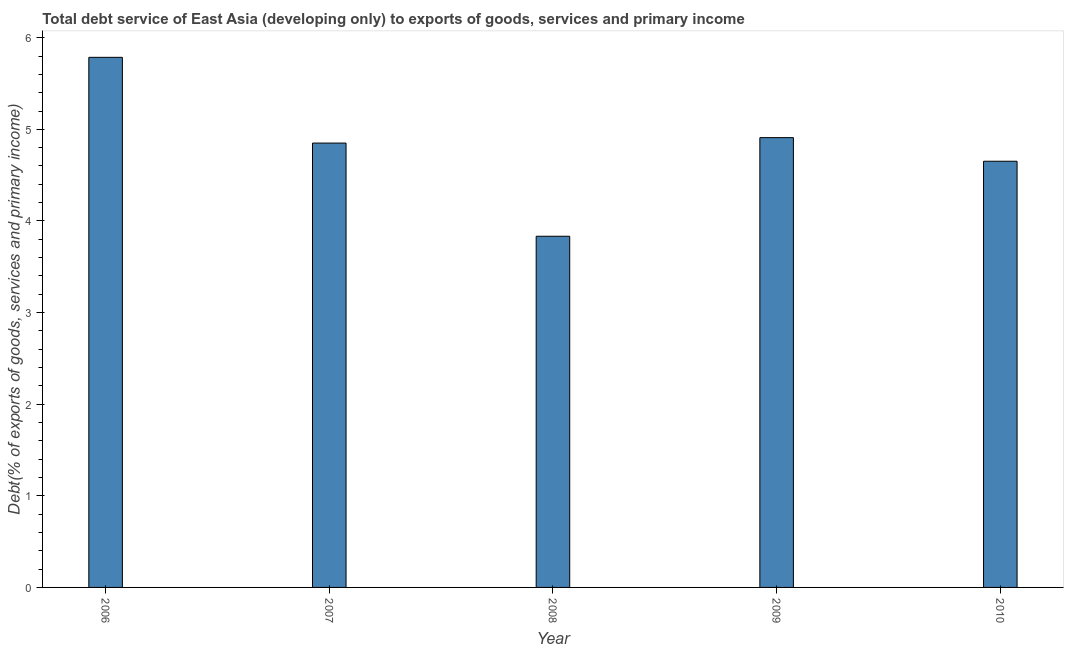Does the graph contain any zero values?
Your answer should be very brief. No. Does the graph contain grids?
Offer a terse response. No. What is the title of the graph?
Your answer should be very brief. Total debt service of East Asia (developing only) to exports of goods, services and primary income. What is the label or title of the Y-axis?
Ensure brevity in your answer.  Debt(% of exports of goods, services and primary income). What is the total debt service in 2008?
Ensure brevity in your answer.  3.83. Across all years, what is the maximum total debt service?
Keep it short and to the point. 5.79. Across all years, what is the minimum total debt service?
Keep it short and to the point. 3.83. In which year was the total debt service maximum?
Your answer should be compact. 2006. In which year was the total debt service minimum?
Offer a very short reply. 2008. What is the sum of the total debt service?
Ensure brevity in your answer.  24.03. What is the difference between the total debt service in 2009 and 2010?
Your answer should be very brief. 0.26. What is the average total debt service per year?
Offer a terse response. 4.81. What is the median total debt service?
Provide a short and direct response. 4.85. Do a majority of the years between 2008 and 2007 (inclusive) have total debt service greater than 0.2 %?
Your response must be concise. No. What is the ratio of the total debt service in 2006 to that in 2009?
Your answer should be very brief. 1.18. Is the total debt service in 2006 less than that in 2008?
Offer a terse response. No. What is the difference between the highest and the second highest total debt service?
Give a very brief answer. 0.88. Is the sum of the total debt service in 2008 and 2010 greater than the maximum total debt service across all years?
Give a very brief answer. Yes. What is the difference between the highest and the lowest total debt service?
Offer a very short reply. 1.95. In how many years, is the total debt service greater than the average total debt service taken over all years?
Your answer should be compact. 3. How many bars are there?
Ensure brevity in your answer.  5. How many years are there in the graph?
Your answer should be compact. 5. What is the Debt(% of exports of goods, services and primary income) in 2006?
Your answer should be very brief. 5.79. What is the Debt(% of exports of goods, services and primary income) of 2007?
Make the answer very short. 4.85. What is the Debt(% of exports of goods, services and primary income) in 2008?
Your answer should be very brief. 3.83. What is the Debt(% of exports of goods, services and primary income) in 2009?
Offer a terse response. 4.91. What is the Debt(% of exports of goods, services and primary income) in 2010?
Ensure brevity in your answer.  4.65. What is the difference between the Debt(% of exports of goods, services and primary income) in 2006 and 2007?
Ensure brevity in your answer.  0.94. What is the difference between the Debt(% of exports of goods, services and primary income) in 2006 and 2008?
Give a very brief answer. 1.95. What is the difference between the Debt(% of exports of goods, services and primary income) in 2006 and 2009?
Provide a short and direct response. 0.88. What is the difference between the Debt(% of exports of goods, services and primary income) in 2006 and 2010?
Your answer should be very brief. 1.13. What is the difference between the Debt(% of exports of goods, services and primary income) in 2007 and 2008?
Keep it short and to the point. 1.02. What is the difference between the Debt(% of exports of goods, services and primary income) in 2007 and 2009?
Offer a terse response. -0.06. What is the difference between the Debt(% of exports of goods, services and primary income) in 2007 and 2010?
Keep it short and to the point. 0.2. What is the difference between the Debt(% of exports of goods, services and primary income) in 2008 and 2009?
Offer a terse response. -1.08. What is the difference between the Debt(% of exports of goods, services and primary income) in 2008 and 2010?
Ensure brevity in your answer.  -0.82. What is the difference between the Debt(% of exports of goods, services and primary income) in 2009 and 2010?
Offer a very short reply. 0.26. What is the ratio of the Debt(% of exports of goods, services and primary income) in 2006 to that in 2007?
Your answer should be compact. 1.19. What is the ratio of the Debt(% of exports of goods, services and primary income) in 2006 to that in 2008?
Your answer should be compact. 1.51. What is the ratio of the Debt(% of exports of goods, services and primary income) in 2006 to that in 2009?
Keep it short and to the point. 1.18. What is the ratio of the Debt(% of exports of goods, services and primary income) in 2006 to that in 2010?
Offer a terse response. 1.24. What is the ratio of the Debt(% of exports of goods, services and primary income) in 2007 to that in 2008?
Offer a very short reply. 1.26. What is the ratio of the Debt(% of exports of goods, services and primary income) in 2007 to that in 2010?
Keep it short and to the point. 1.04. What is the ratio of the Debt(% of exports of goods, services and primary income) in 2008 to that in 2009?
Your answer should be compact. 0.78. What is the ratio of the Debt(% of exports of goods, services and primary income) in 2008 to that in 2010?
Provide a short and direct response. 0.82. What is the ratio of the Debt(% of exports of goods, services and primary income) in 2009 to that in 2010?
Your response must be concise. 1.05. 